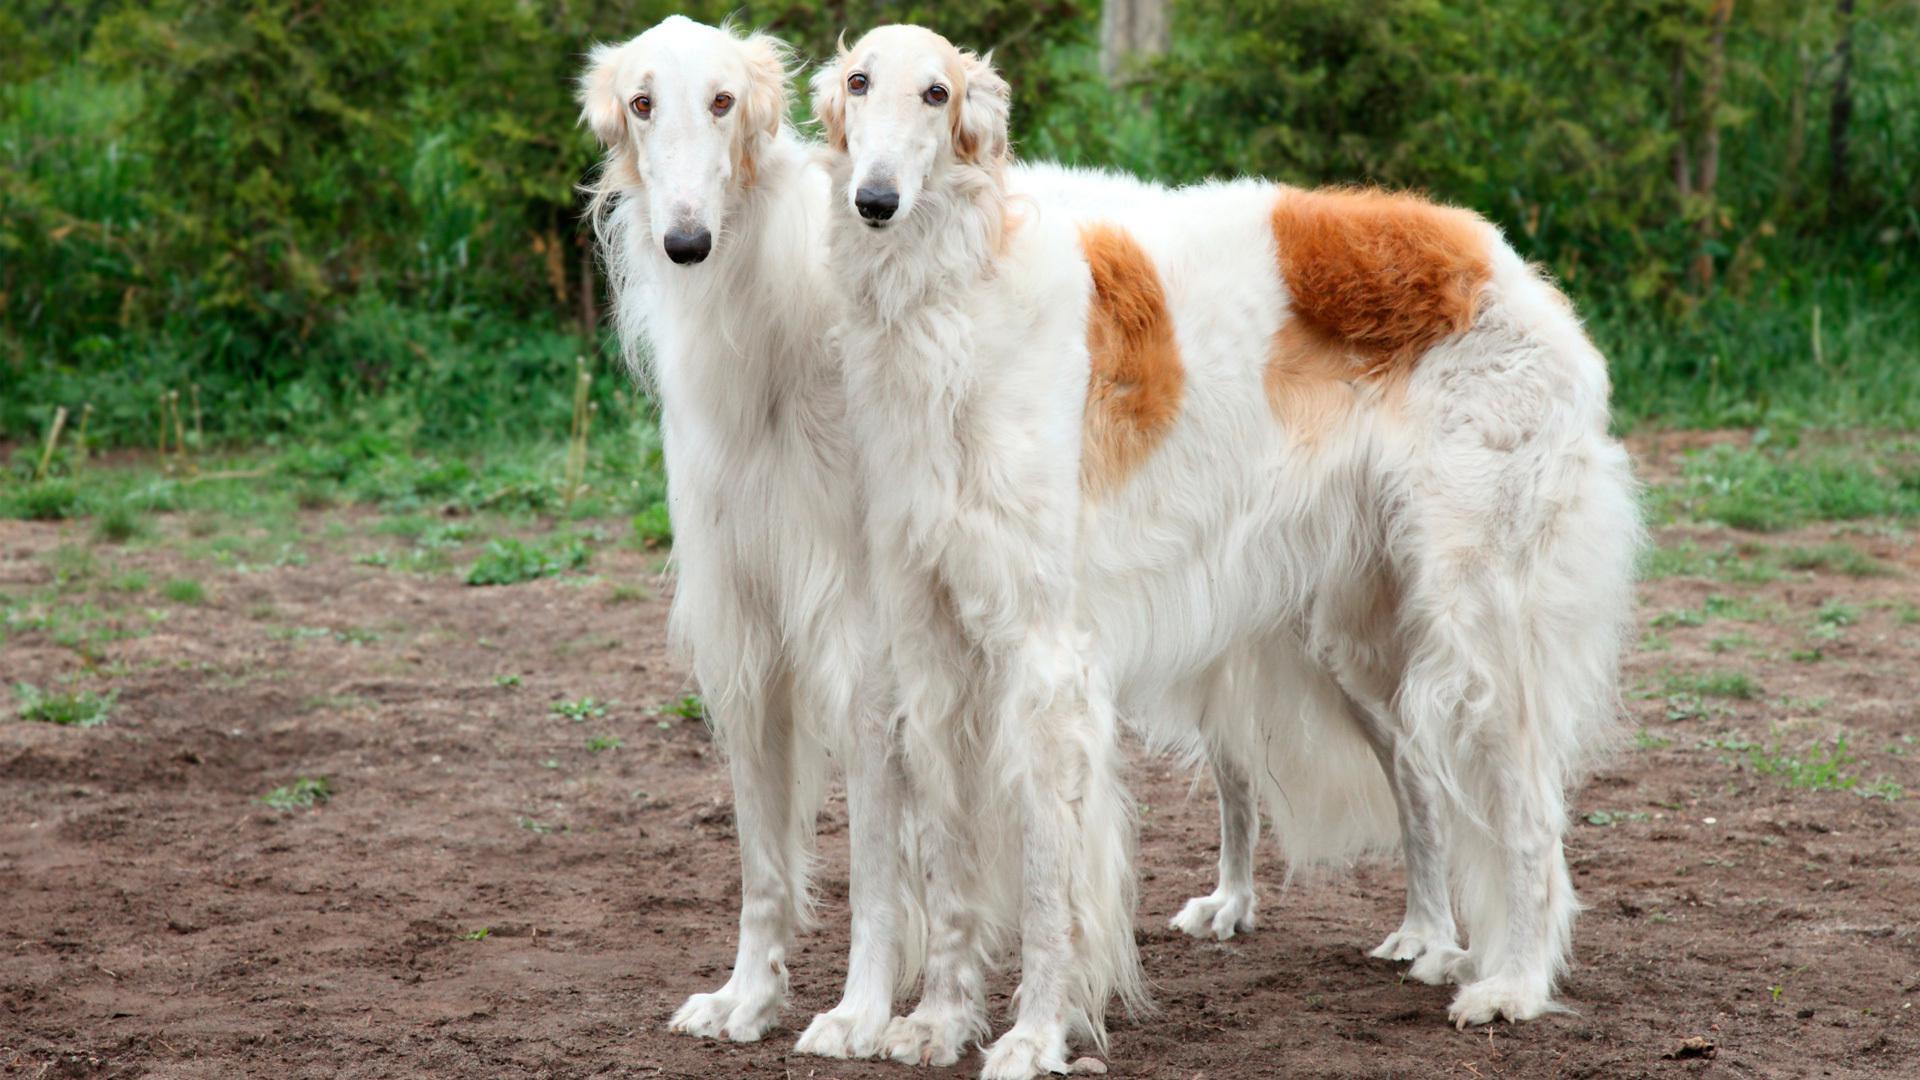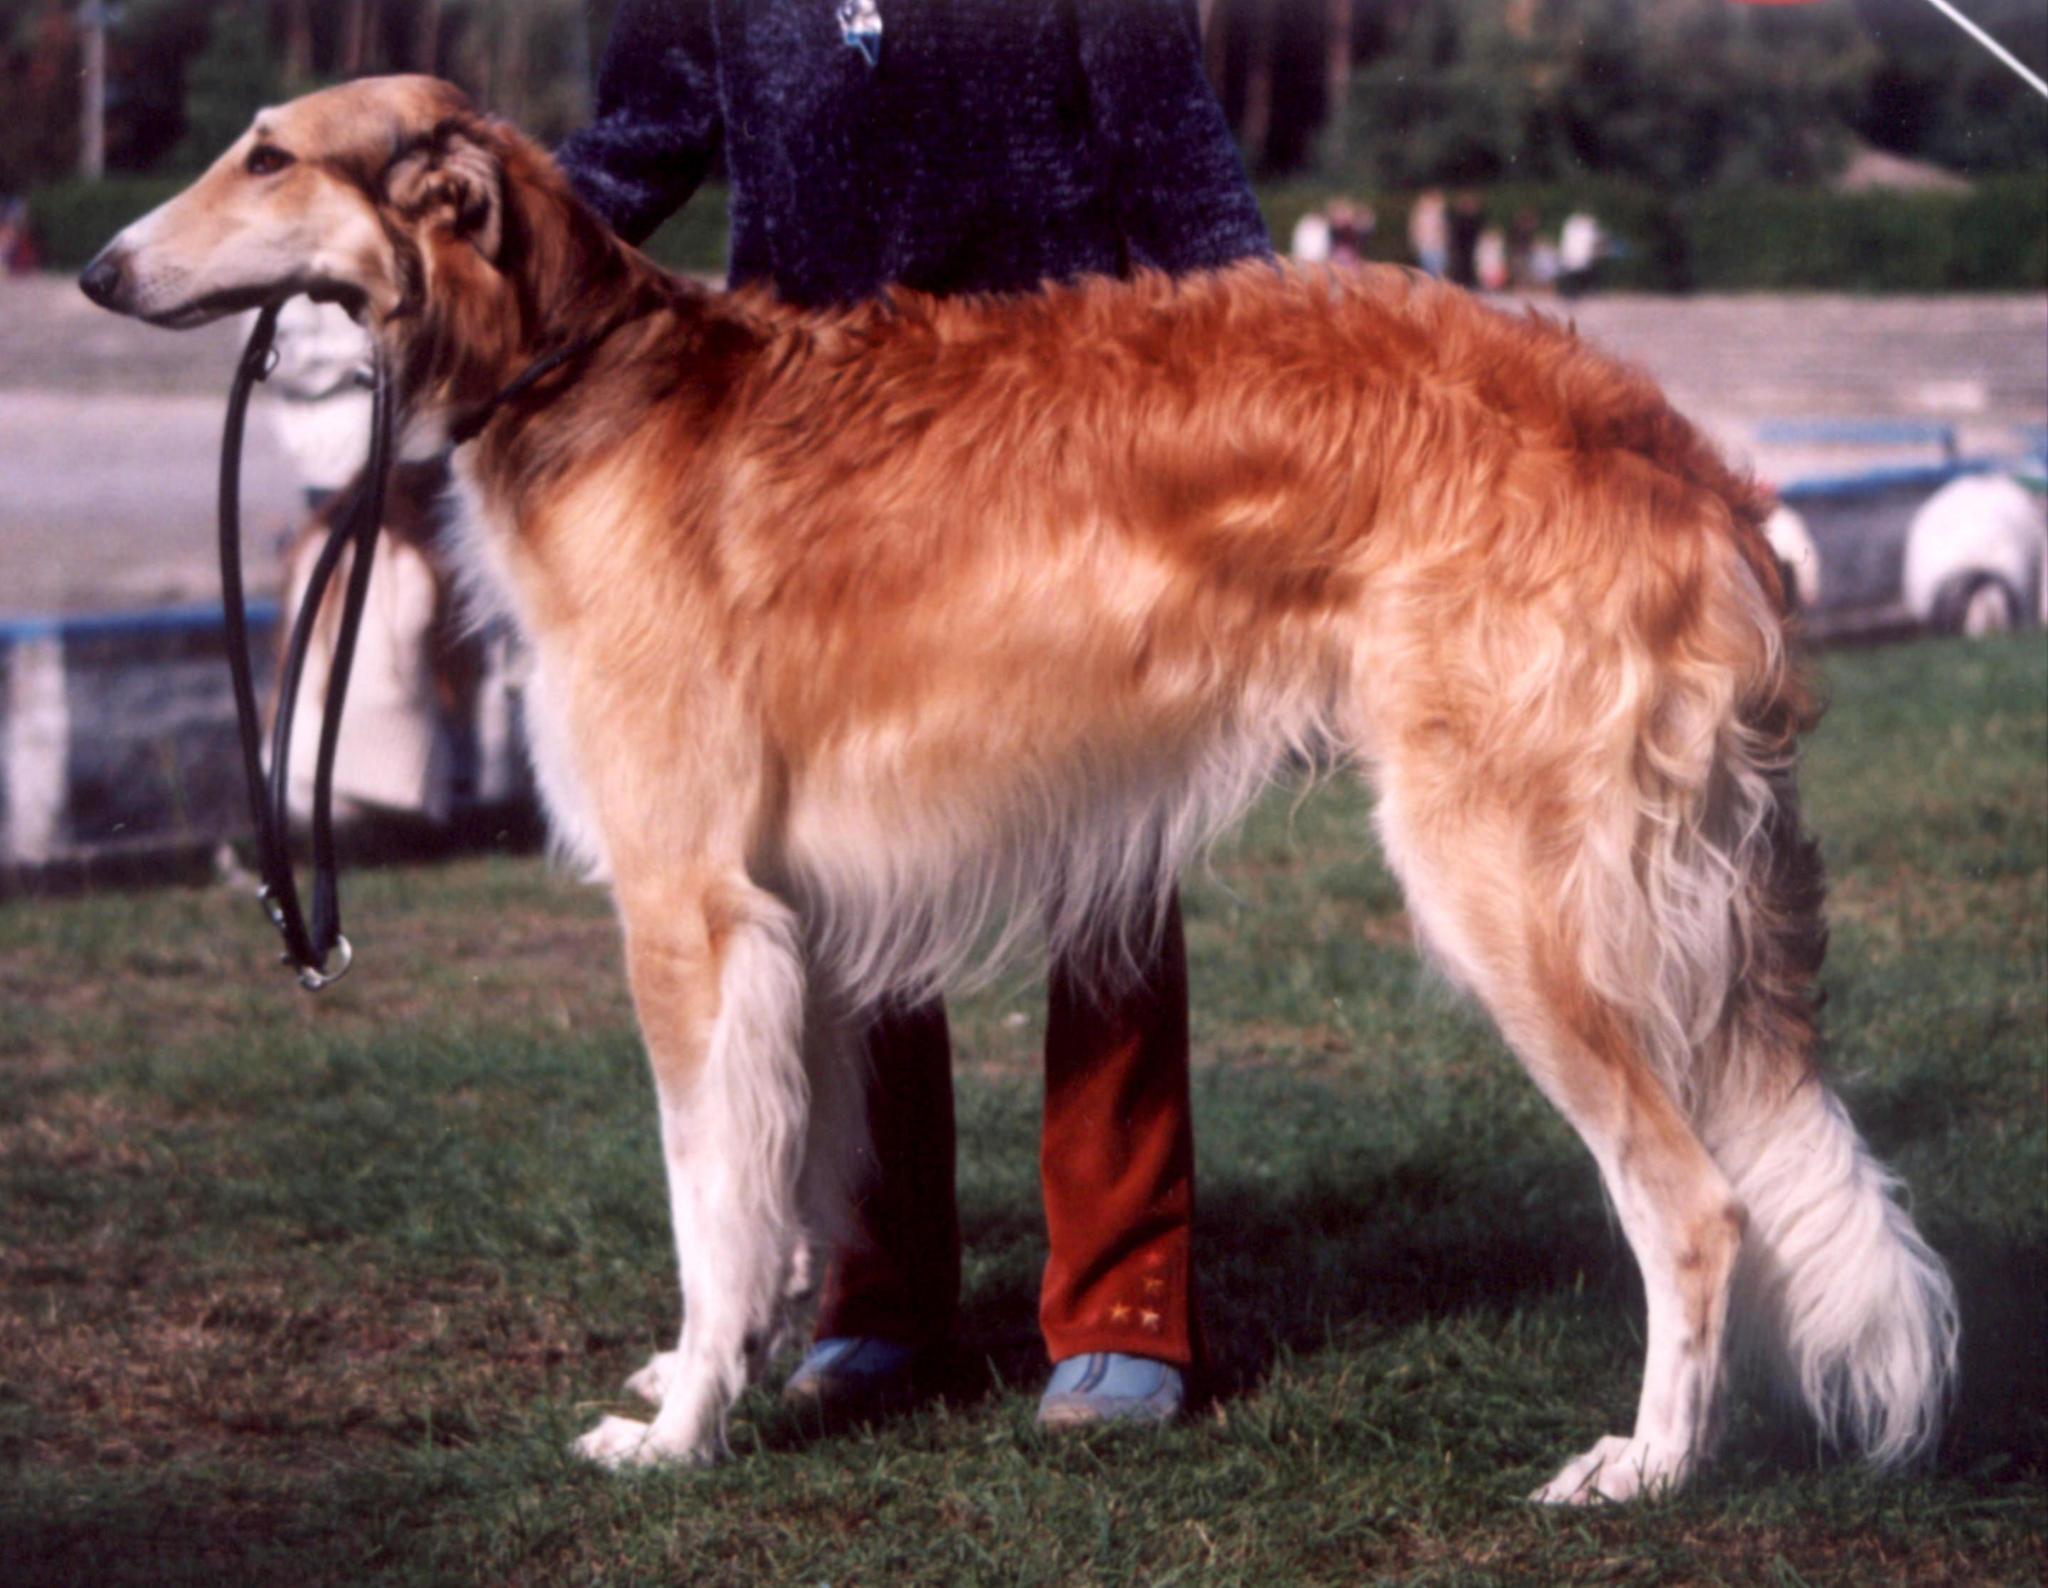The first image is the image on the left, the second image is the image on the right. Evaluate the accuracy of this statement regarding the images: "The dogs in the image on the left are facing right.". Is it true? Answer yes or no. No. 